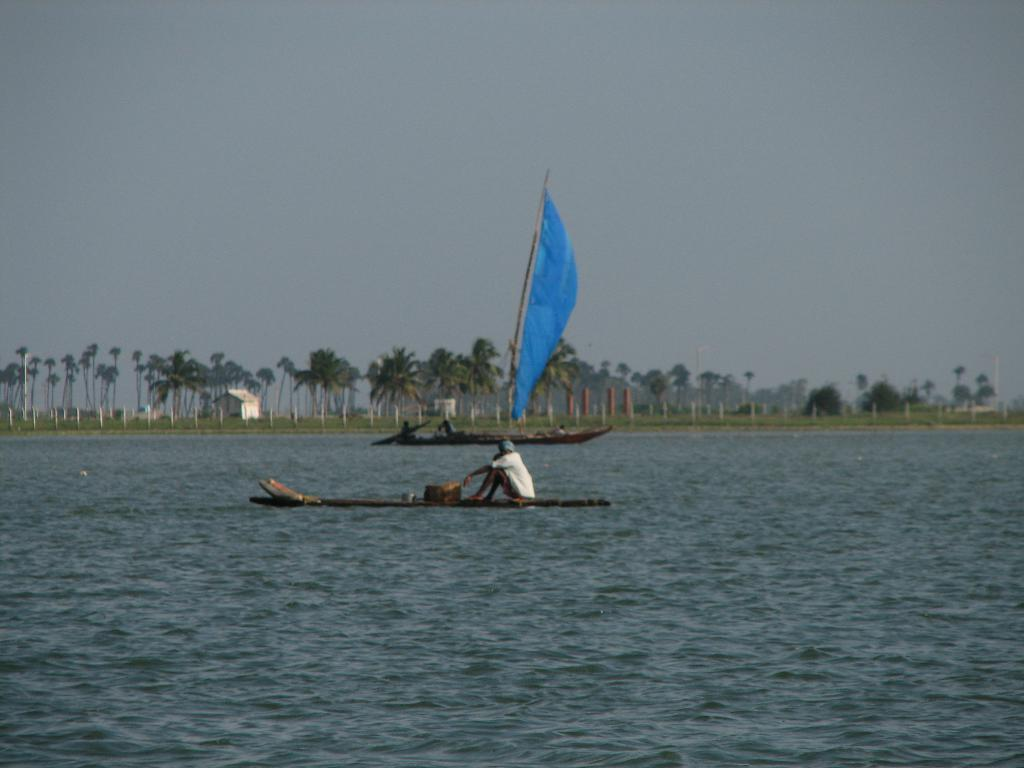What are the people in the image doing? The people in the image are sailing boats. Where are the boats located? The boats are on the water. What can be seen in the background of the image? There are trees, houses, poles, and the sky visible in the background of the image. What type of ring can be seen on the cabbage in the image? There is no ring or cabbage present in the image; it features people sailing boats on the water. What color is the cloth used to cover the boats in the image? There is no cloth covering the boats in the image; the boats are on the water and visible. 